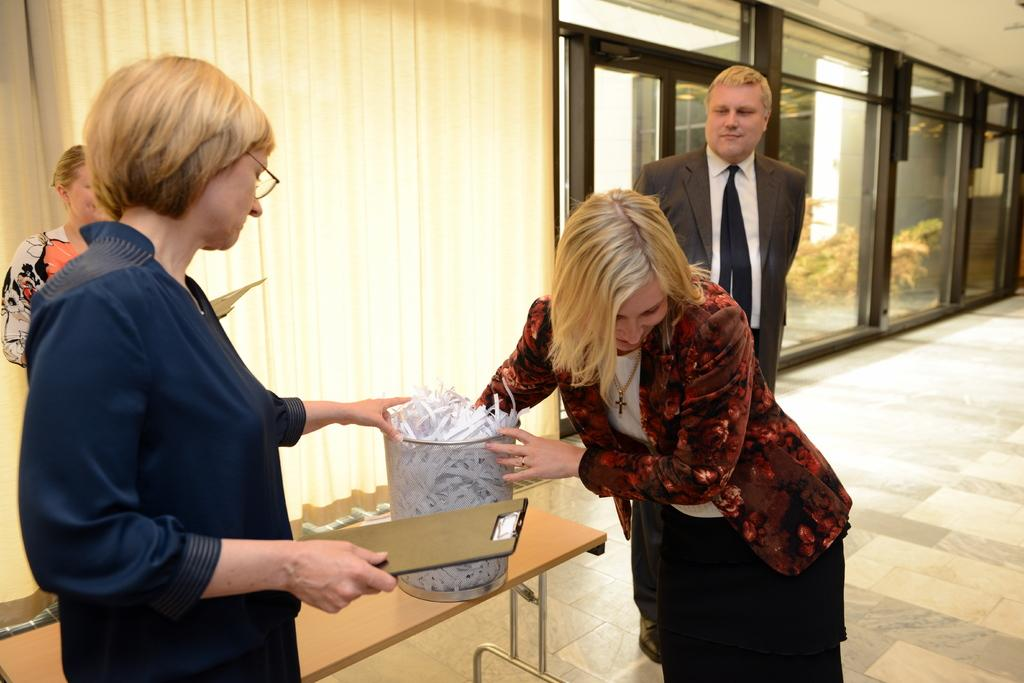What can be seen in the image regarding the people present? There is a group of women and a man in the image. What are the women doing in the image? The women are standing and holding a basket in their hands. Can you describe the man's position in the image? The man is standing in the image. What other object is visible in the image? There is a table in the image. What type of music is being played by the hook in the image? There is no hook or music present in the image. What tool is the man using to fix the wrench in the image? There is no wrench or tool present in the image. 